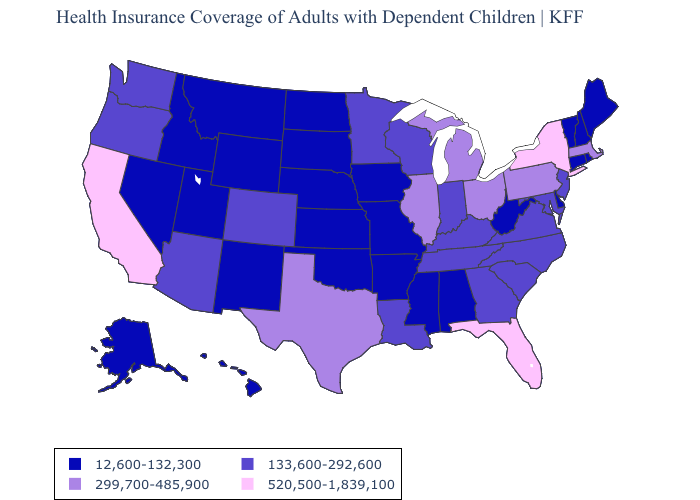What is the value of Illinois?
Be succinct. 299,700-485,900. Name the states that have a value in the range 520,500-1,839,100?
Be succinct. California, Florida, New York. Among the states that border California , does Arizona have the highest value?
Give a very brief answer. Yes. What is the highest value in the Northeast ?
Quick response, please. 520,500-1,839,100. Does the map have missing data?
Keep it brief. No. Does Maine have the highest value in the USA?
Write a very short answer. No. Does Florida have the same value as Iowa?
Be succinct. No. What is the highest value in the MidWest ?
Answer briefly. 299,700-485,900. What is the value of Wyoming?
Write a very short answer. 12,600-132,300. Name the states that have a value in the range 520,500-1,839,100?
Answer briefly. California, Florida, New York. Does Oregon have a lower value than Arizona?
Be succinct. No. Does the map have missing data?
Write a very short answer. No. What is the lowest value in the South?
Write a very short answer. 12,600-132,300. Does Alaska have the highest value in the USA?
Write a very short answer. No. What is the value of Delaware?
Write a very short answer. 12,600-132,300. 